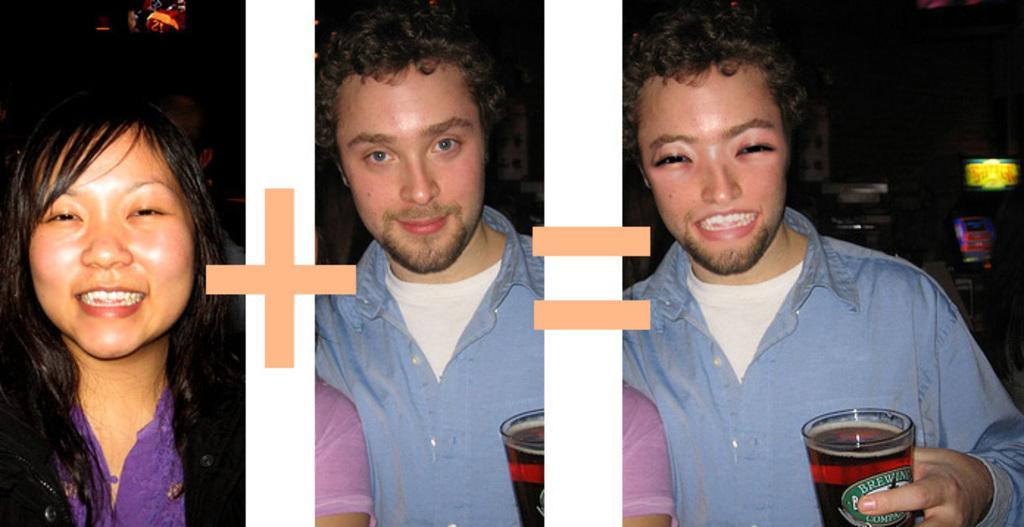Please provide a concise description of this image. There is a woman she is wearing an purple color dress, she is smiling and leaving her hair. and there is a person who is wearing a blue color t-shirt ,and he is smiling. there is a person who is smiling he is catching a wine glass in his hand. 